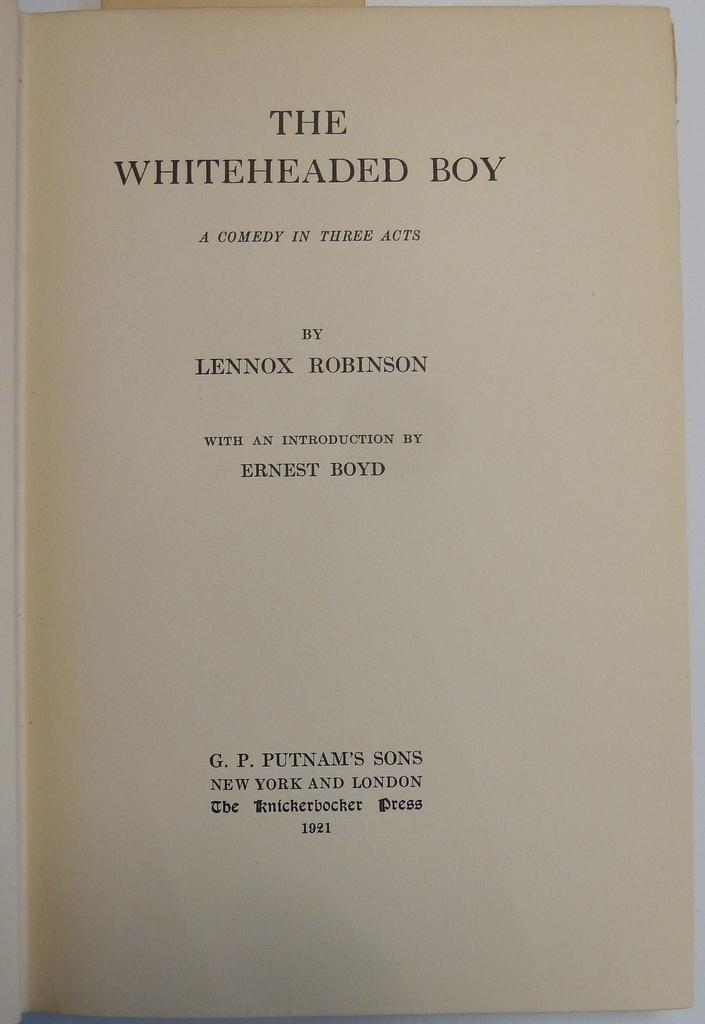<image>
Provide a brief description of the given image. A book titled The Whiteheaded Boy by the author Lennox Robinson. 